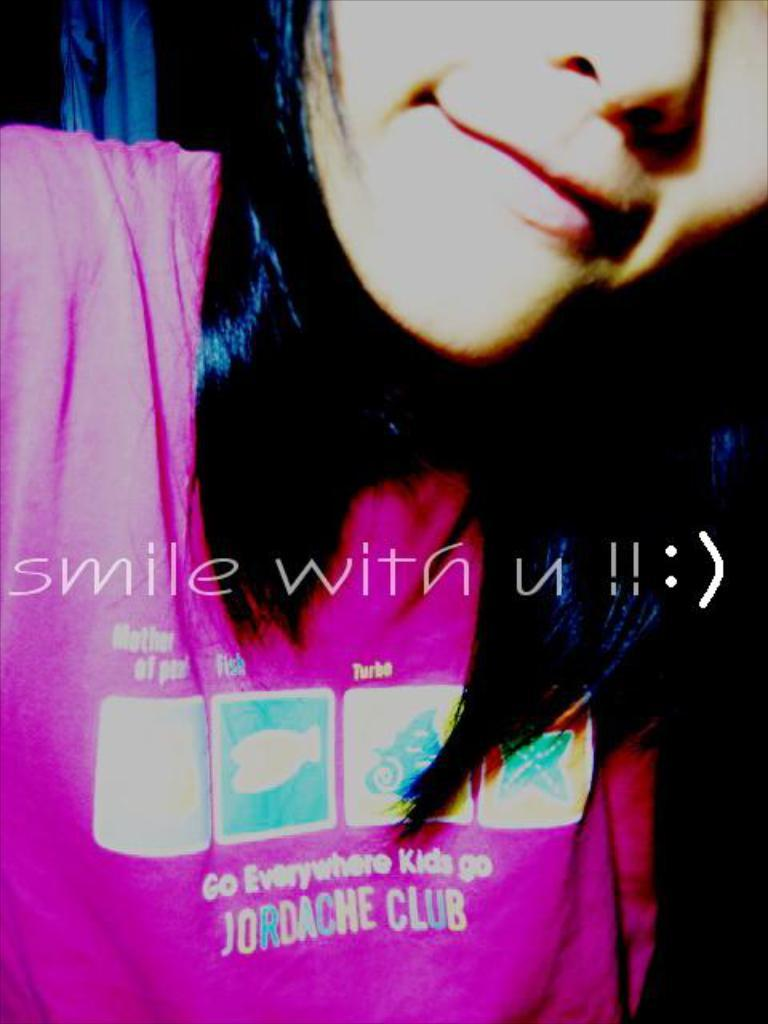Who is the main subject in the image? There is a lady in the image. What is unique about the lady's t-shirt? The lady's t-shirt has images and text on it. Can you read any text in the image? Yes, there is text visible on the image. How much profit does the lady make in the image? There is no information about profit in the image, as it focuses on the lady and her t-shirt. What force is being applied to the lady in the image? There is no force being applied to the lady in the image; she is standing still. 